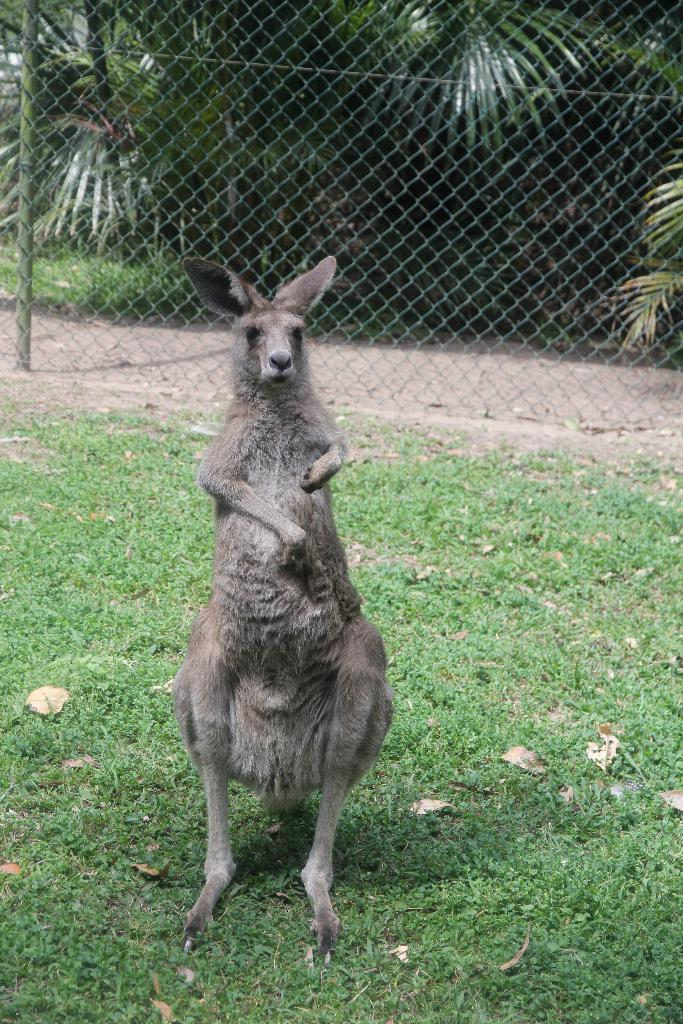What animal is present in the image? There is a kangaroo in the image. Where is the kangaroo located? The kangaroo is on a grass field. What structures can be seen at the top of the image? There is a fence, a pole, and a group of trees visible at the top of the image. What type of statement can be seen written on the kangaroo's pouch in the image? There is no statement written on the kangaroo's pouch in the image. What tool is the kangaroo using to fix the fence in the image? The kangaroo is not using any tool to fix the fence in the image, as there is no fence-fixing activity depicted. 